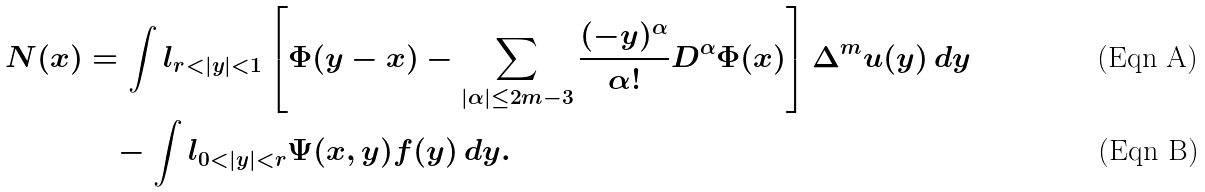<formula> <loc_0><loc_0><loc_500><loc_500>N ( x ) & = \int l _ { r < | y | < 1 } \left [ \Phi ( y - x ) - \sum _ { | \alpha | \leq 2 m - 3 } \frac { ( - y ) ^ { \alpha } } { \alpha ! } D ^ { \alpha } \Phi ( x ) \right ] \Delta ^ { m } u ( y ) \, d y \\ & \quad - \int l _ { 0 < | y | < r } \Psi ( x , y ) f ( y ) \, d y .</formula> 